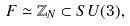<formula> <loc_0><loc_0><loc_500><loc_500>F \simeq \mathbb { Z } _ { N } \subset S U ( 3 ) ,</formula> 